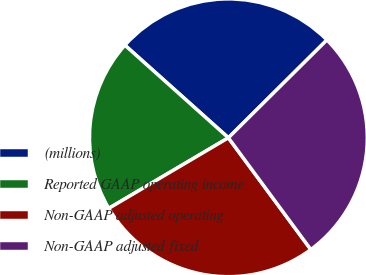Convert chart to OTSL. <chart><loc_0><loc_0><loc_500><loc_500><pie_chart><fcel>(millions)<fcel>Reported GAAP operating income<fcel>Non-GAAP adjusted operating<fcel>Non-GAAP adjusted fixed<nl><fcel>25.94%<fcel>20.1%<fcel>26.63%<fcel>27.33%<nl></chart> 